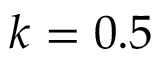Convert formula to latex. <formula><loc_0><loc_0><loc_500><loc_500>k = 0 . 5</formula> 